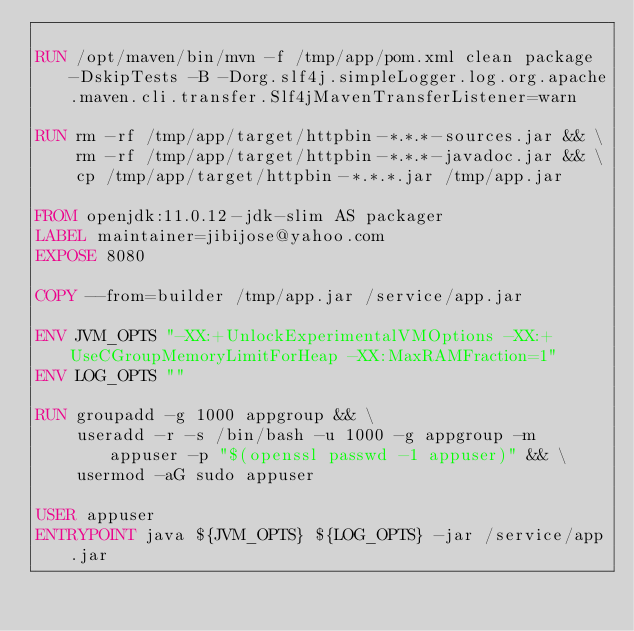Convert code to text. <code><loc_0><loc_0><loc_500><loc_500><_Dockerfile_>
RUN /opt/maven/bin/mvn -f /tmp/app/pom.xml clean package -DskipTests -B -Dorg.slf4j.simpleLogger.log.org.apache.maven.cli.transfer.Slf4jMavenTransferListener=warn

RUN rm -rf /tmp/app/target/httpbin-*.*.*-sources.jar && \
    rm -rf /tmp/app/target/httpbin-*.*.*-javadoc.jar && \
    cp /tmp/app/target/httpbin-*.*.*.jar /tmp/app.jar

FROM openjdk:11.0.12-jdk-slim AS packager
LABEL maintainer=jibijose@yahoo.com
EXPOSE 8080

COPY --from=builder /tmp/app.jar /service/app.jar

ENV JVM_OPTS "-XX:+UnlockExperimentalVMOptions -XX:+UseCGroupMemoryLimitForHeap -XX:MaxRAMFraction=1"
ENV LOG_OPTS ""

RUN groupadd -g 1000 appgroup && \
    useradd -r -s /bin/bash -u 1000 -g appgroup -m appuser -p "$(openssl passwd -1 appuser)" && \
    usermod -aG sudo appuser

USER appuser
ENTRYPOINT java ${JVM_OPTS} ${LOG_OPTS} -jar /service/app.jar
</code> 